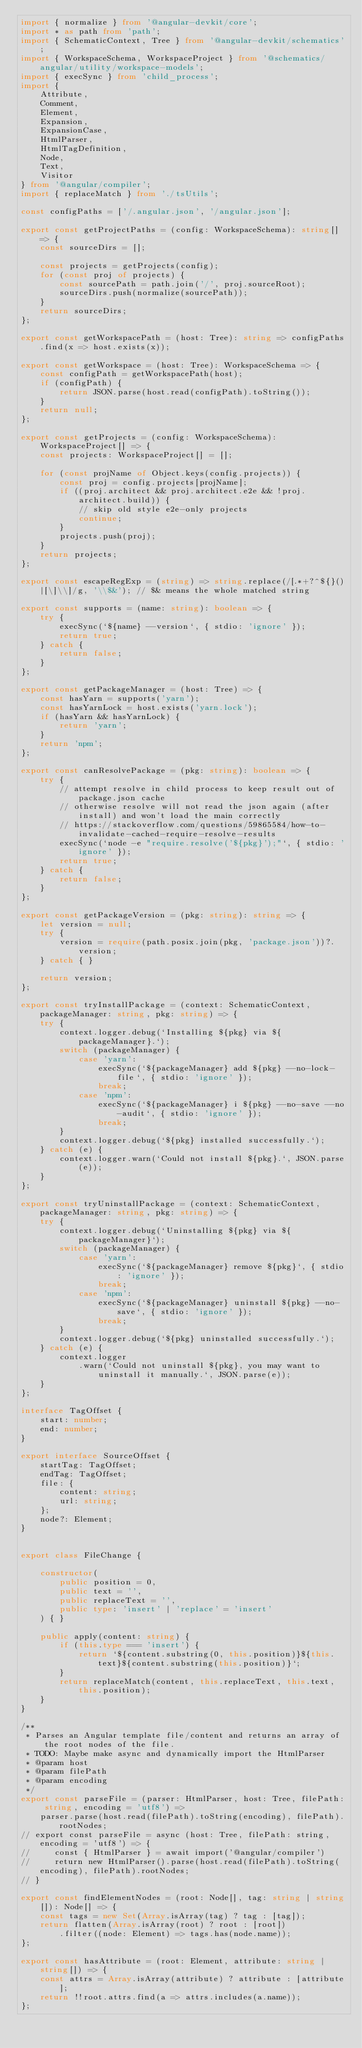<code> <loc_0><loc_0><loc_500><loc_500><_TypeScript_>import { normalize } from '@angular-devkit/core';
import * as path from 'path';
import { SchematicContext, Tree } from '@angular-devkit/schematics';
import { WorkspaceSchema, WorkspaceProject } from '@schematics/angular/utility/workspace-models';
import { execSync } from 'child_process';
import {
    Attribute,
    Comment,
    Element,
    Expansion,
    ExpansionCase,
    HtmlParser,
    HtmlTagDefinition,
    Node,
    Text,
    Visitor
} from '@angular/compiler';
import { replaceMatch } from './tsUtils';

const configPaths = ['/.angular.json', '/angular.json'];

export const getProjectPaths = (config: WorkspaceSchema): string[] => {
    const sourceDirs = [];

    const projects = getProjects(config);
    for (const proj of projects) {
        const sourcePath = path.join('/', proj.sourceRoot);
        sourceDirs.push(normalize(sourcePath));
    }
    return sourceDirs;
};

export const getWorkspacePath = (host: Tree): string => configPaths.find(x => host.exists(x));

export const getWorkspace = (host: Tree): WorkspaceSchema => {
    const configPath = getWorkspacePath(host);
    if (configPath) {
        return JSON.parse(host.read(configPath).toString());
    }
    return null;
};

export const getProjects = (config: WorkspaceSchema): WorkspaceProject[] => {
    const projects: WorkspaceProject[] = [];

    for (const projName of Object.keys(config.projects)) {
        const proj = config.projects[projName];
        if ((proj.architect && proj.architect.e2e && !proj.architect.build)) {
            // skip old style e2e-only projects
            continue;
        }
        projects.push(proj);
    }
    return projects;
};

export const escapeRegExp = (string) => string.replace(/[.*+?^${}()|[\]\\]/g, '\\$&'); // $& means the whole matched string

export const supports = (name: string): boolean => {
    try {
        execSync(`${name} --version`, { stdio: 'ignore' });
        return true;
    } catch {
        return false;
    }
};

export const getPackageManager = (host: Tree) => {
    const hasYarn = supports('yarn');
    const hasYarnLock = host.exists('yarn.lock');
    if (hasYarn && hasYarnLock) {
        return 'yarn';
    }
    return 'npm';
};

export const canResolvePackage = (pkg: string): boolean => {
    try {
        // attempt resolve in child process to keep result out of package.json cache
        // otherwise resolve will not read the json again (after install) and won't load the main correctly
        // https://stackoverflow.com/questions/59865584/how-to-invalidate-cached-require-resolve-results
        execSync(`node -e "require.resolve('${pkg}');"`, { stdio: 'ignore' });
        return true;
    } catch {
        return false;
    }
};

export const getPackageVersion = (pkg: string): string => {
    let version = null;
    try {
        version = require(path.posix.join(pkg, 'package.json'))?.version;
    } catch { }

    return version;
};

export const tryInstallPackage = (context: SchematicContext, packageManager: string, pkg: string) => {
    try {
        context.logger.debug(`Installing ${pkg} via ${packageManager}.`);
        switch (packageManager) {
            case 'yarn':
                execSync(`${packageManager} add ${pkg} --no-lock-file`, { stdio: 'ignore' });
                break;
            case 'npm':
                execSync(`${packageManager} i ${pkg} --no-save --no-audit`, { stdio: 'ignore' });
                break;
        }
        context.logger.debug(`${pkg} installed successfully.`);
    } catch (e) {
        context.logger.warn(`Could not install ${pkg}.`, JSON.parse(e));
    }
};

export const tryUninstallPackage = (context: SchematicContext, packageManager: string, pkg: string) => {
    try {
        context.logger.debug(`Uninstalling ${pkg} via ${packageManager}`);
        switch (packageManager) {
            case 'yarn':
                execSync(`${packageManager} remove ${pkg}`, { stdio: 'ignore' });
                break;
            case 'npm':
                execSync(`${packageManager} uninstall ${pkg} --no-save`, { stdio: 'ignore' });
                break;
        }
        context.logger.debug(`${pkg} uninstalled successfully.`);
    } catch (e) {
        context.logger
            .warn(`Could not uninstall ${pkg}, you may want to uninstall it manually.`, JSON.parse(e));
    }
};

interface TagOffset {
    start: number;
    end: number;
}

export interface SourceOffset {
    startTag: TagOffset;
    endTag: TagOffset;
    file: {
        content: string;
        url: string;
    };
    node?: Element;
}


export class FileChange {

    constructor(
        public position = 0,
        public text = '',
        public replaceText = '',
        public type: 'insert' | 'replace' = 'insert'
    ) { }

    public apply(content: string) {
        if (this.type === 'insert') {
            return `${content.substring(0, this.position)}${this.text}${content.substring(this.position)}`;
        }
        return replaceMatch(content, this.replaceText, this.text, this.position);
    }
}

/**
 * Parses an Angular template file/content and returns an array of the root nodes of the file.
 * TODO: Maybe make async and dynamically import the HtmlParser
 * @param host
 * @param filePath
 * @param encoding
 */
export const parseFile = (parser: HtmlParser, host: Tree, filePath: string, encoding = 'utf8') =>
    parser.parse(host.read(filePath).toString(encoding), filePath).rootNodes;
// export const parseFile = async (host: Tree, filePath: string, encoding = 'utf8') => {
//     const { HtmlParser } = await import('@angular/compiler')
//     return new HtmlParser().parse(host.read(filePath).toString(encoding), filePath).rootNodes;
// }

export const findElementNodes = (root: Node[], tag: string | string[]): Node[] => {
    const tags = new Set(Array.isArray(tag) ? tag : [tag]);
    return flatten(Array.isArray(root) ? root : [root])
        .filter((node: Element) => tags.has(node.name));
};

export const hasAttribute = (root: Element, attribute: string | string[]) => {
    const attrs = Array.isArray(attribute) ? attribute : [attribute];
    return !!root.attrs.find(a => attrs.includes(a.name));
};
</code> 